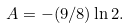<formula> <loc_0><loc_0><loc_500><loc_500>A = - ( 9 / 8 ) \ln 2 .</formula> 